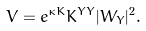Convert formula to latex. <formula><loc_0><loc_0><loc_500><loc_500>V = e ^ { \kappa K } K ^ { Y \bar { Y } } | W _ { Y } | ^ { 2 } .</formula> 